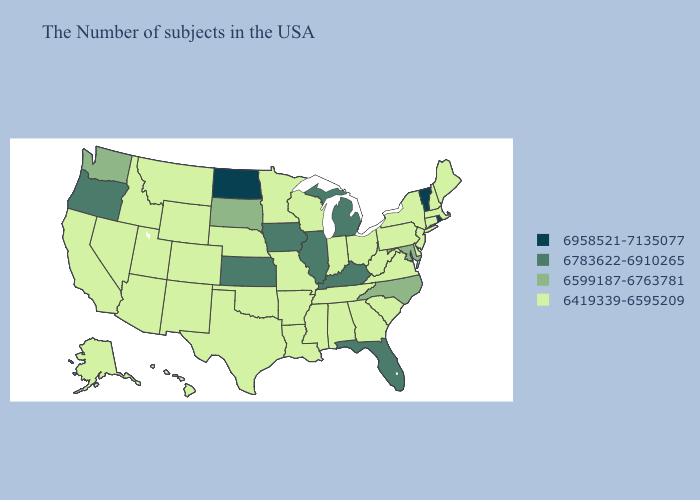What is the highest value in the USA?
Concise answer only. 6958521-7135077. What is the highest value in states that border South Dakota?
Write a very short answer. 6958521-7135077. Name the states that have a value in the range 6958521-7135077?
Keep it brief. Rhode Island, Vermont, North Dakota. Name the states that have a value in the range 6958521-7135077?
Answer briefly. Rhode Island, Vermont, North Dakota. What is the value of Nevada?
Keep it brief. 6419339-6595209. What is the value of North Carolina?
Concise answer only. 6599187-6763781. Does Hawaii have a lower value than Oregon?
Concise answer only. Yes. Name the states that have a value in the range 6599187-6763781?
Concise answer only. Maryland, North Carolina, South Dakota, Washington. Does Indiana have the lowest value in the USA?
Answer briefly. Yes. Is the legend a continuous bar?
Answer briefly. No. Does California have the same value as Maryland?
Answer briefly. No. What is the highest value in states that border Missouri?
Write a very short answer. 6783622-6910265. What is the highest value in the South ?
Concise answer only. 6783622-6910265. Does Florida have the same value as Kansas?
Write a very short answer. Yes. What is the value of Louisiana?
Keep it brief. 6419339-6595209. 